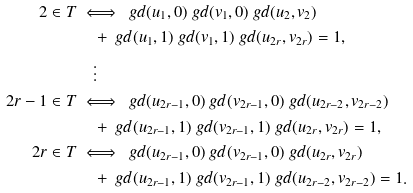Convert formula to latex. <formula><loc_0><loc_0><loc_500><loc_500>2 \in T & \iff \ g d ( u _ { 1 } , 0 ) \ g d ( v _ { 1 } , 0 ) \ g d ( u _ { 2 } , v _ { 2 } ) \\ & \quad + \ g d ( u _ { 1 } , 1 ) \ g d ( v _ { 1 } , 1 ) \ g d ( u _ { 2 r } , v _ { 2 r } ) = 1 , \\ & \quad \vdots \\ 2 r - 1 \in T & \iff \ g d ( u _ { 2 r - 1 } , 0 ) \ g d ( v _ { 2 r - 1 } , 0 ) \ g d ( u _ { 2 r - 2 } , v _ { 2 r - 2 } ) \\ & \quad + \ g d ( u _ { 2 r - 1 } , 1 ) \ g d ( v _ { 2 r - 1 } , 1 ) \ g d ( u _ { 2 r } , v _ { 2 r } ) = 1 , \\ 2 r \in T & \iff \ g d ( u _ { 2 r - 1 } , 0 ) \ g d ( v _ { 2 r - 1 } , 0 ) \ g d ( u _ { 2 r } , v _ { 2 r } ) \\ & \quad + \ g d ( u _ { 2 r - 1 } , 1 ) \ g d ( v _ { 2 r - 1 } , 1 ) \ g d ( u _ { 2 r - 2 } , v _ { 2 r - 2 } ) = 1 .</formula> 